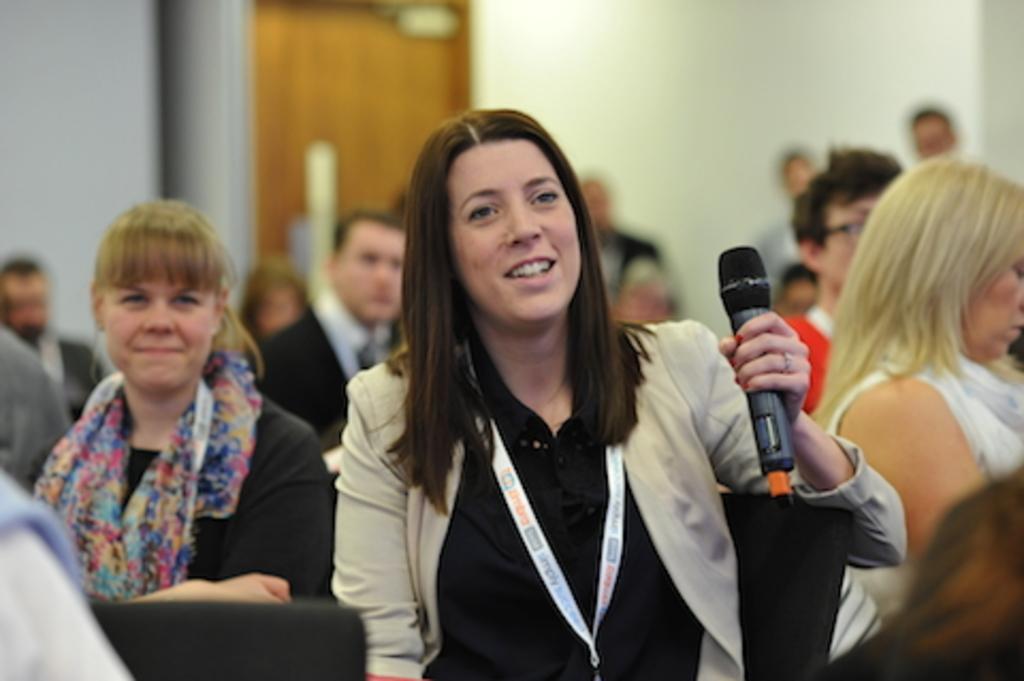How would you summarize this image in a sentence or two? In this picture I can see few people seated and few are standing and I can see a woman holding a microphone and looks like she wore a ID card and I can see a door in the back. 